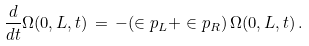<formula> <loc_0><loc_0><loc_500><loc_500>\frac { d } { d t } \Omega ( 0 , L , t ) \, = \, - ( \in p _ { L } + \in p _ { R } ) \, \Omega ( 0 , L , t ) \, .</formula> 